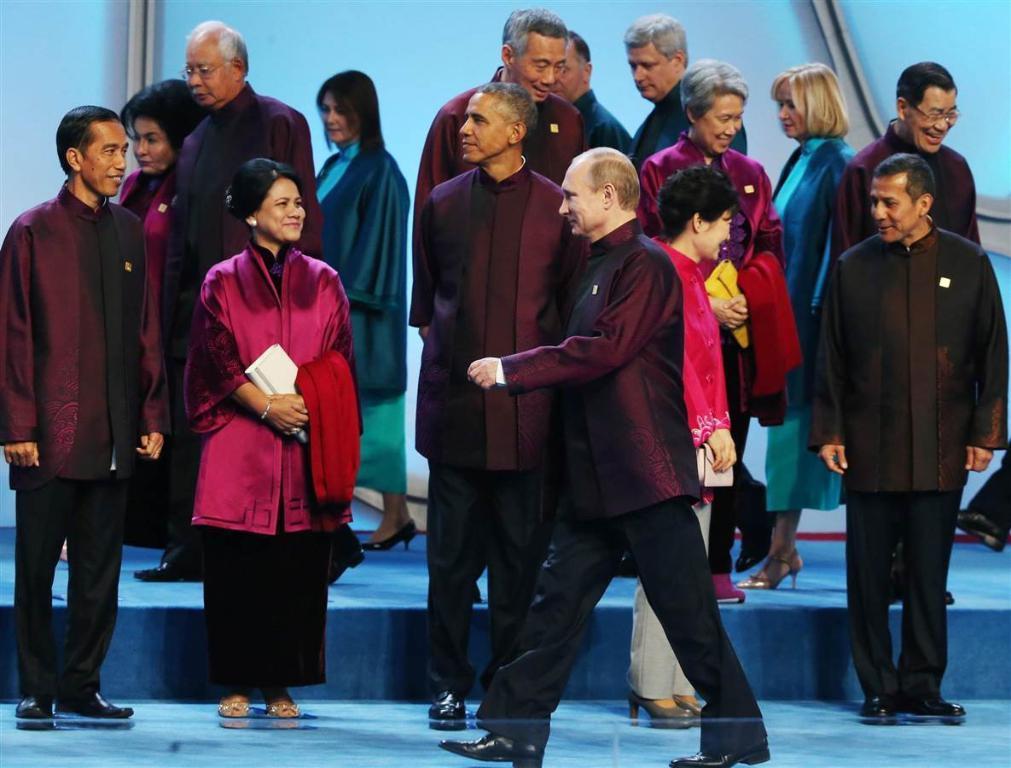Please provide a concise description of this image. In this image I can see a group of people standing and walking. Some of them are interacting with each other. 